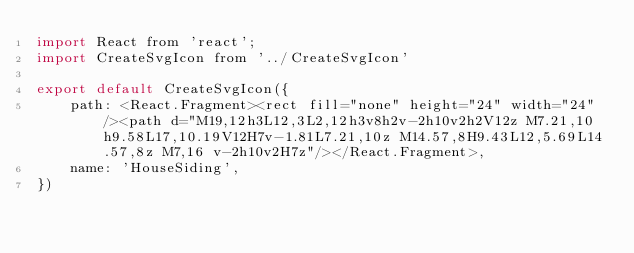<code> <loc_0><loc_0><loc_500><loc_500><_JavaScript_>import React from 'react';
import CreateSvgIcon from '../CreateSvgIcon'

export default CreateSvgIcon({
    path: <React.Fragment><rect fill="none" height="24" width="24"/><path d="M19,12h3L12,3L2,12h3v8h2v-2h10v2h2V12z M7.21,10h9.58L17,10.19V12H7v-1.81L7.21,10z M14.57,8H9.43L12,5.69L14.57,8z M7,16 v-2h10v2H7z"/></React.Fragment>,
    name: 'HouseSiding',
})</code> 